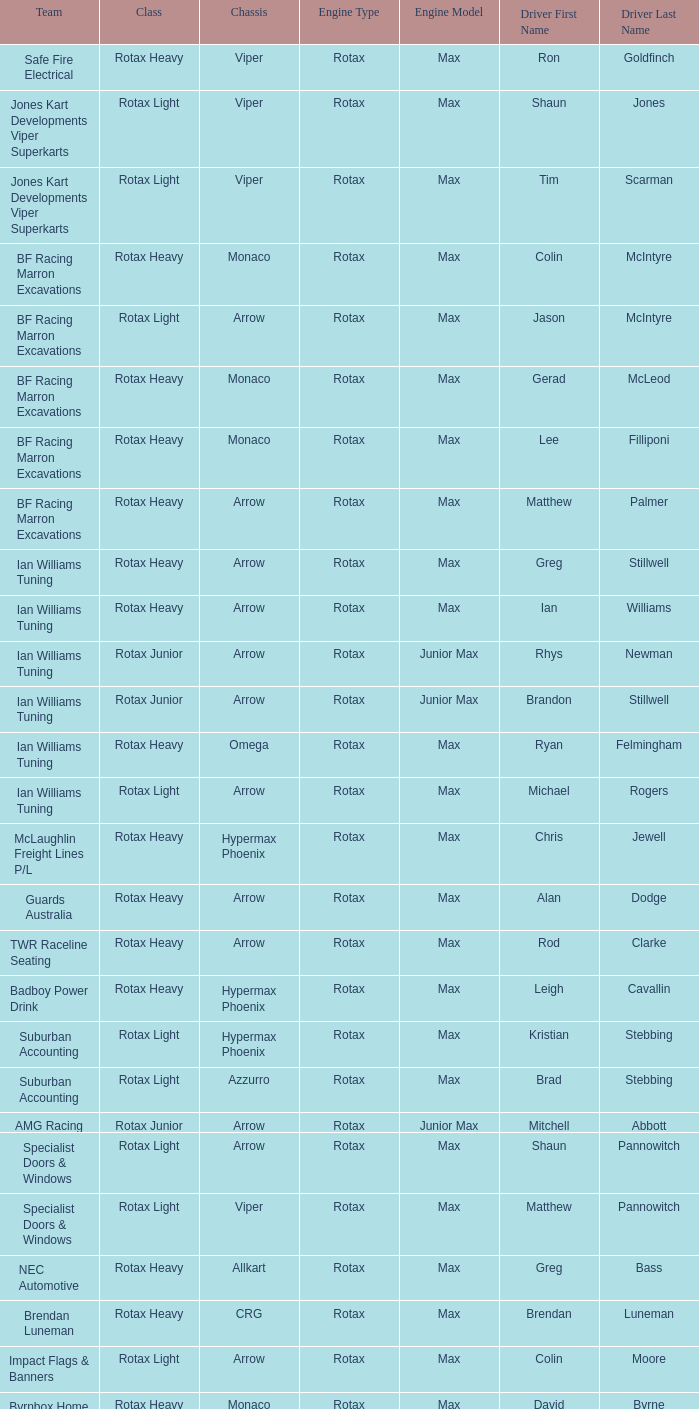What is the name of the driver with a rotax max engine, in the rotax heavy class, with arrow as chassis and on the TWR Raceline Seating team? Rod Clarke. 